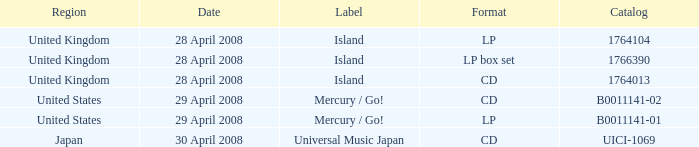What is the district of the 1766390 catalog? United Kingdom. 